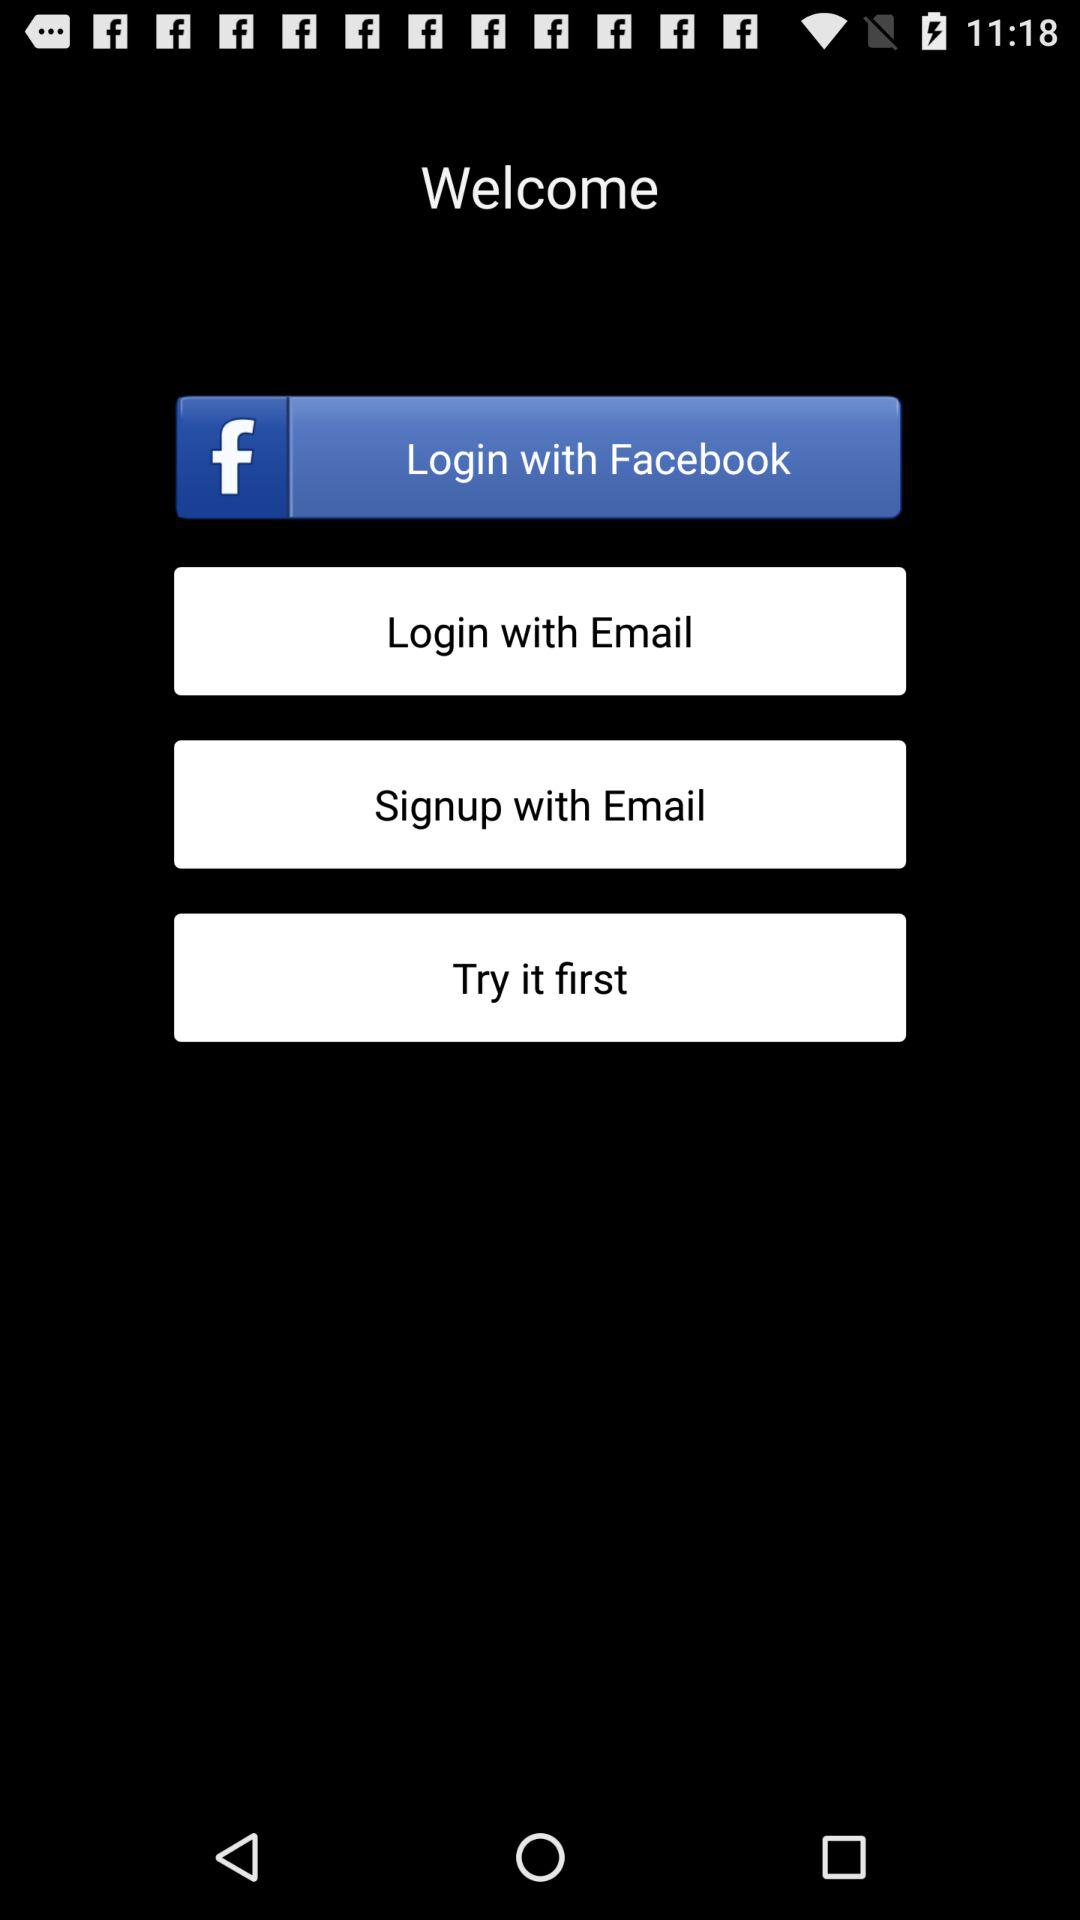Through what accounts can login be done? The accounts are "Facebook" and "Email". 